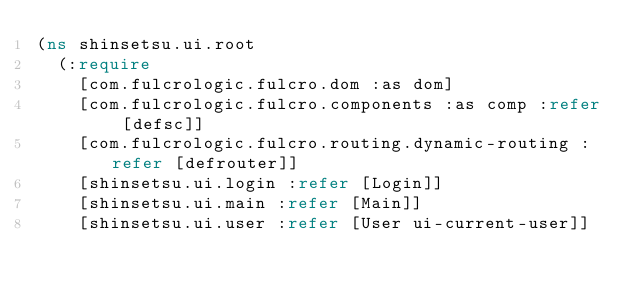<code> <loc_0><loc_0><loc_500><loc_500><_Clojure_>(ns shinsetsu.ui.root
  (:require
    [com.fulcrologic.fulcro.dom :as dom]
    [com.fulcrologic.fulcro.components :as comp :refer [defsc]]
    [com.fulcrologic.fulcro.routing.dynamic-routing :refer [defrouter]]
    [shinsetsu.ui.login :refer [Login]]
    [shinsetsu.ui.main :refer [Main]]
    [shinsetsu.ui.user :refer [User ui-current-user]]</code> 